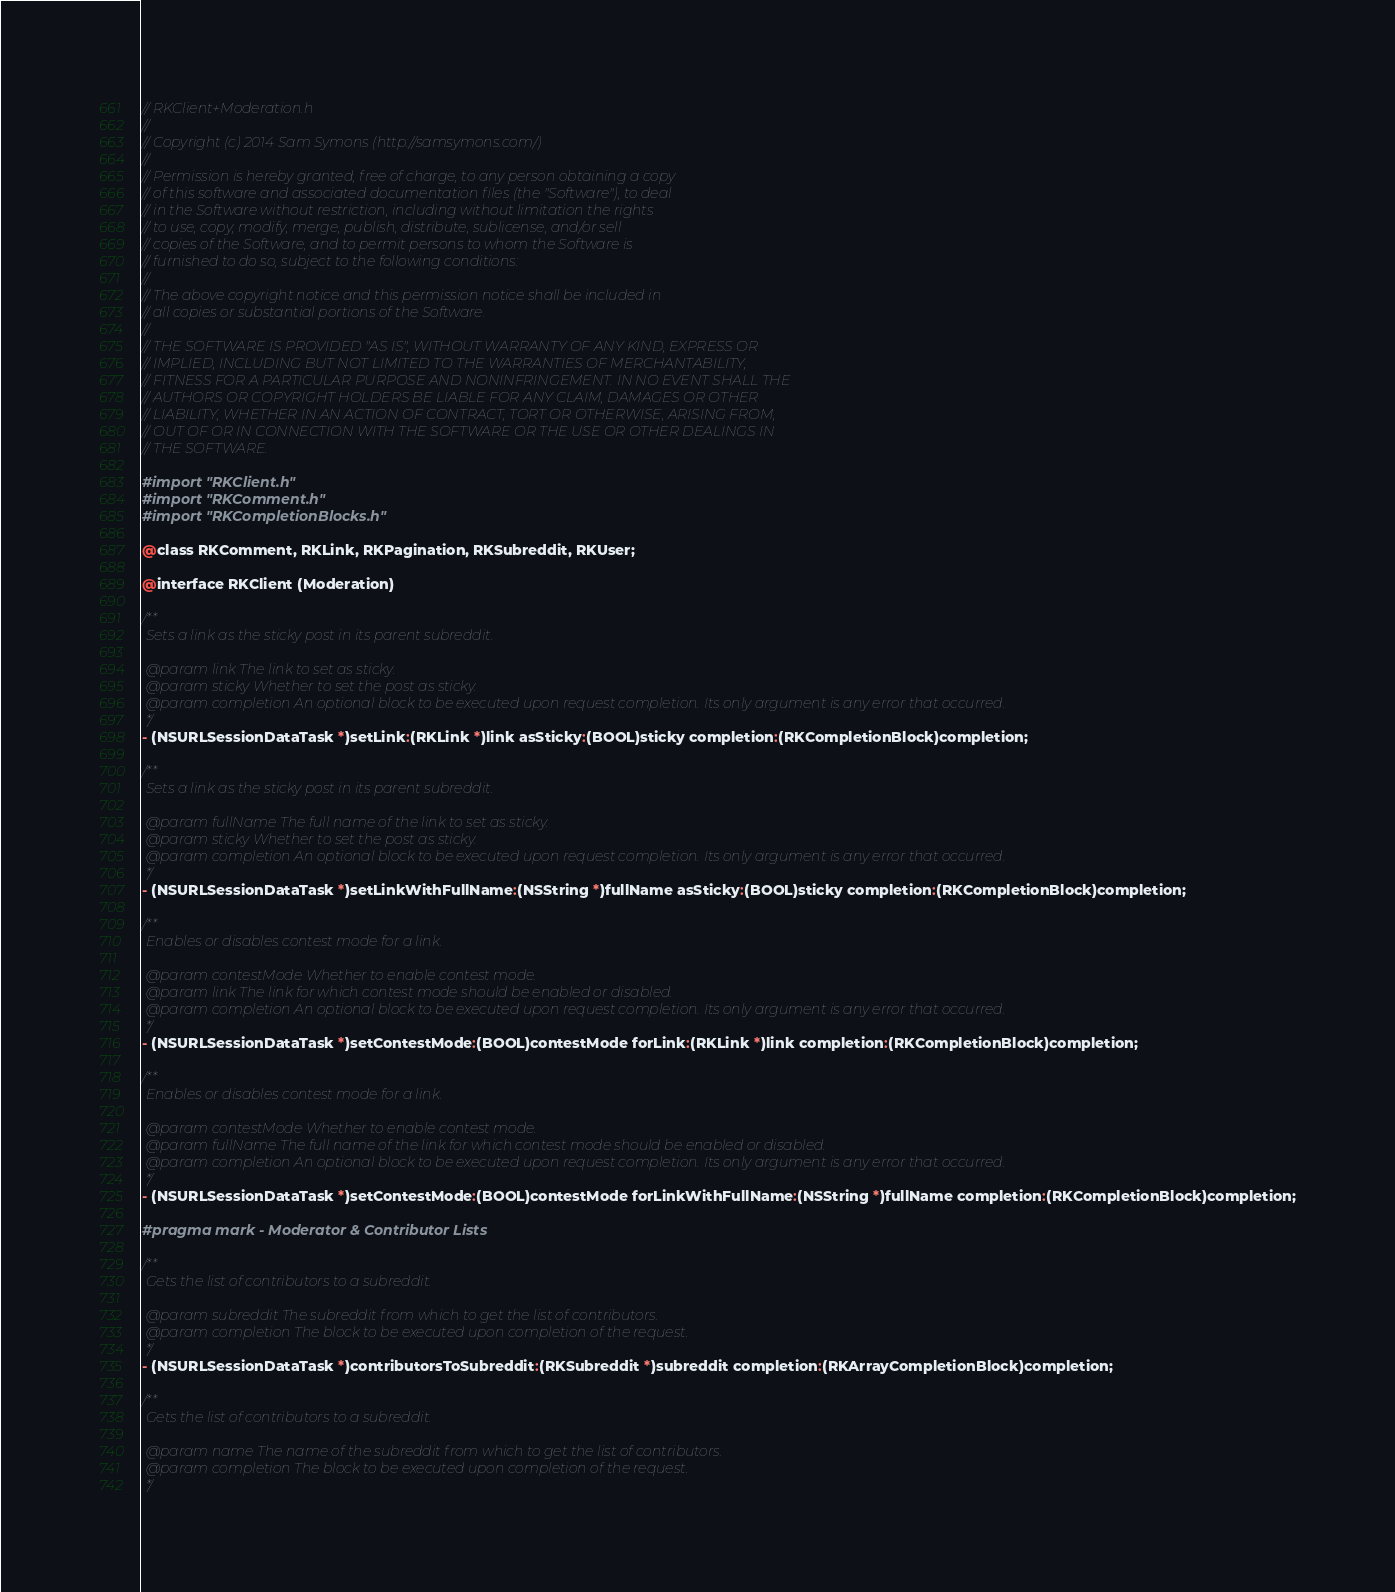Convert code to text. <code><loc_0><loc_0><loc_500><loc_500><_C_>// RKClient+Moderation.h
//
// Copyright (c) 2014 Sam Symons (http://samsymons.com/)
//
// Permission is hereby granted, free of charge, to any person obtaining a copy
// of this software and associated documentation files (the "Software"), to deal
// in the Software without restriction, including without limitation the rights
// to use, copy, modify, merge, publish, distribute, sublicense, and/or sell
// copies of the Software, and to permit persons to whom the Software is
// furnished to do so, subject to the following conditions:
//
// The above copyright notice and this permission notice shall be included in
// all copies or substantial portions of the Software.
//
// THE SOFTWARE IS PROVIDED "AS IS", WITHOUT WARRANTY OF ANY KIND, EXPRESS OR
// IMPLIED, INCLUDING BUT NOT LIMITED TO THE WARRANTIES OF MERCHANTABILITY,
// FITNESS FOR A PARTICULAR PURPOSE AND NONINFRINGEMENT. IN NO EVENT SHALL THE
// AUTHORS OR COPYRIGHT HOLDERS BE LIABLE FOR ANY CLAIM, DAMAGES OR OTHER
// LIABILITY, WHETHER IN AN ACTION OF CONTRACT, TORT OR OTHERWISE, ARISING FROM,
// OUT OF OR IN CONNECTION WITH THE SOFTWARE OR THE USE OR OTHER DEALINGS IN
// THE SOFTWARE.

#import "RKClient.h"
#import "RKComment.h"
#import "RKCompletionBlocks.h"

@class RKComment, RKLink, RKPagination, RKSubreddit, RKUser;

@interface RKClient (Moderation)

/**
 Sets a link as the sticky post in its parent subreddit.
 
 @param link The link to set as sticky.
 @param sticky Whether to set the post as sticky.
 @param completion An optional block to be executed upon request completion. Its only argument is any error that occurred.
 */
- (NSURLSessionDataTask *)setLink:(RKLink *)link asSticky:(BOOL)sticky completion:(RKCompletionBlock)completion;

/**
 Sets a link as the sticky post in its parent subreddit.
 
 @param fullName The full name of the link to set as sticky.
 @param sticky Whether to set the post as sticky.
 @param completion An optional block to be executed upon request completion. Its only argument is any error that occurred.
 */
- (NSURLSessionDataTask *)setLinkWithFullName:(NSString *)fullName asSticky:(BOOL)sticky completion:(RKCompletionBlock)completion;

/**
 Enables or disables contest mode for a link.
 
 @param contestMode Whether to enable contest mode.
 @param link The link for which contest mode should be enabled or disabled.
 @param completion An optional block to be executed upon request completion. Its only argument is any error that occurred.
 */
- (NSURLSessionDataTask *)setContestMode:(BOOL)contestMode forLink:(RKLink *)link completion:(RKCompletionBlock)completion;

/**
 Enables or disables contest mode for a link.
 
 @param contestMode Whether to enable contest mode.
 @param fullName The full name of the link for which contest mode should be enabled or disabled.
 @param completion An optional block to be executed upon request completion. Its only argument is any error that occurred.
 */
- (NSURLSessionDataTask *)setContestMode:(BOOL)contestMode forLinkWithFullName:(NSString *)fullName completion:(RKCompletionBlock)completion;

#pragma mark - Moderator & Contributor Lists

/**
 Gets the list of contributors to a subreddit.
 
 @param subreddit The subreddit from which to get the list of contributors.
 @param completion The block to be executed upon completion of the request.
 */
- (NSURLSessionDataTask *)contributorsToSubreddit:(RKSubreddit *)subreddit completion:(RKArrayCompletionBlock)completion;

/**
 Gets the list of contributors to a subreddit.
 
 @param name The name of the subreddit from which to get the list of contributors.
 @param completion The block to be executed upon completion of the request.
 */</code> 